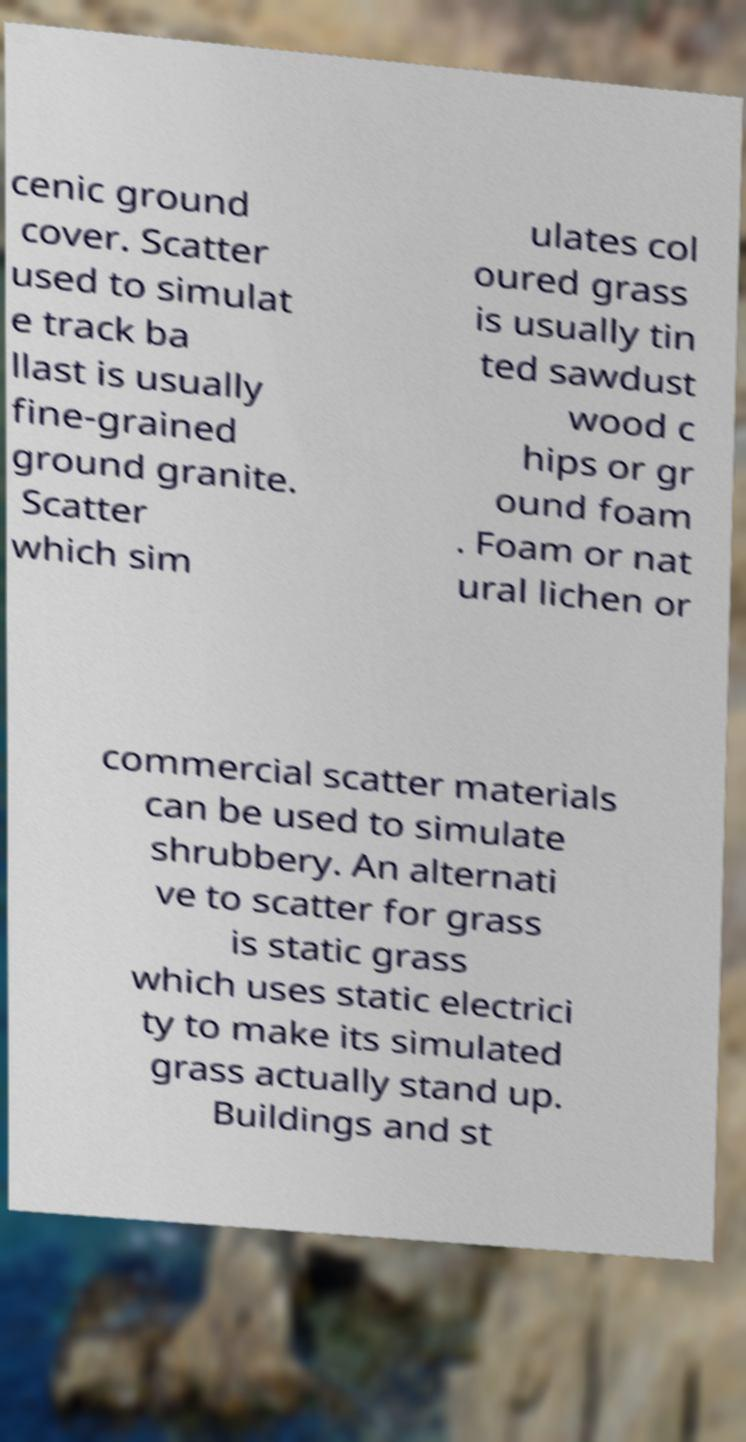Could you assist in decoding the text presented in this image and type it out clearly? cenic ground cover. Scatter used to simulat e track ba llast is usually fine-grained ground granite. Scatter which sim ulates col oured grass is usually tin ted sawdust wood c hips or gr ound foam . Foam or nat ural lichen or commercial scatter materials can be used to simulate shrubbery. An alternati ve to scatter for grass is static grass which uses static electrici ty to make its simulated grass actually stand up. Buildings and st 